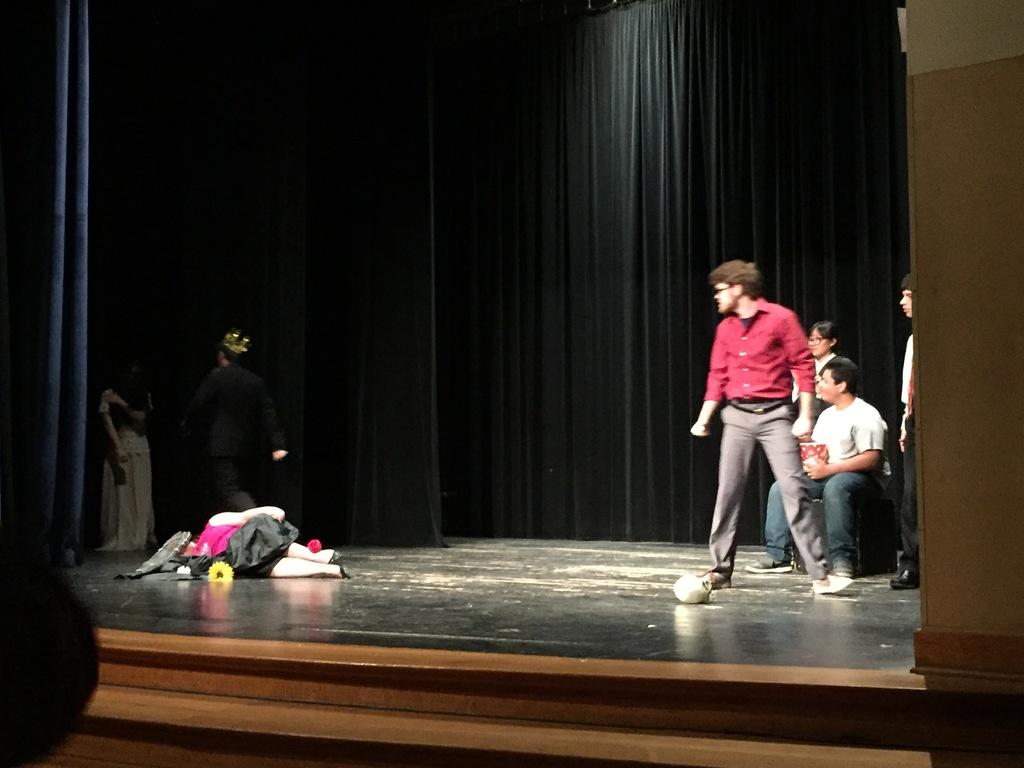What is happening on the right side of the stage? There are persons standing on the right side of the stage. What is happening on the left side of the stage? There are persons standing on the left side of the stage. What is the position of the woman on the stage? A woman is laying in the middle of the stage. What does the woman have in her possession? The woman has a flower. What can be seen in the background of the stage? There is a curtain in the background of the stage. What type of country is depicted in the image? There is no country depicted in the image; it is a stage with persons, a woman, and a curtain. What is the woman using to quiver in the image? The woman is not using anything to quiver in the image; she is laying on the stage with a flower. 